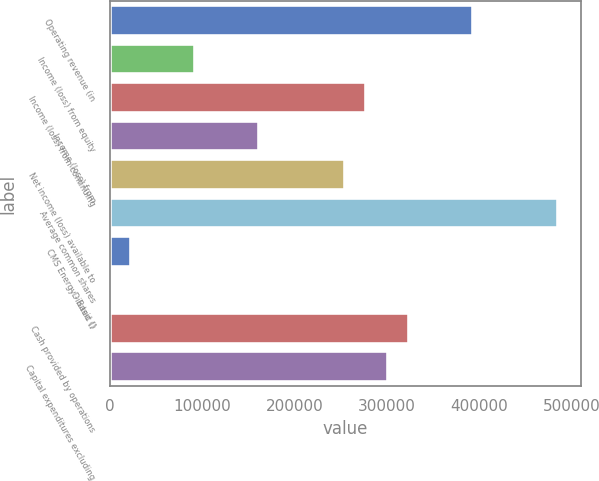<chart> <loc_0><loc_0><loc_500><loc_500><bar_chart><fcel>Operating revenue (in<fcel>Income (loss) from equity<fcel>Income (loss) from continuing<fcel>Income (loss) from<fcel>Net income (loss) available to<fcel>Average common shares<fcel>CMS Energy - Basic ()<fcel>- Diluted ()<fcel>Cash provided by operations<fcel>Capital expenditures excluding<nl><fcel>393503<fcel>92590<fcel>277767<fcel>162031<fcel>254620<fcel>486092<fcel>23148.5<fcel>1.36<fcel>324062<fcel>300914<nl></chart> 